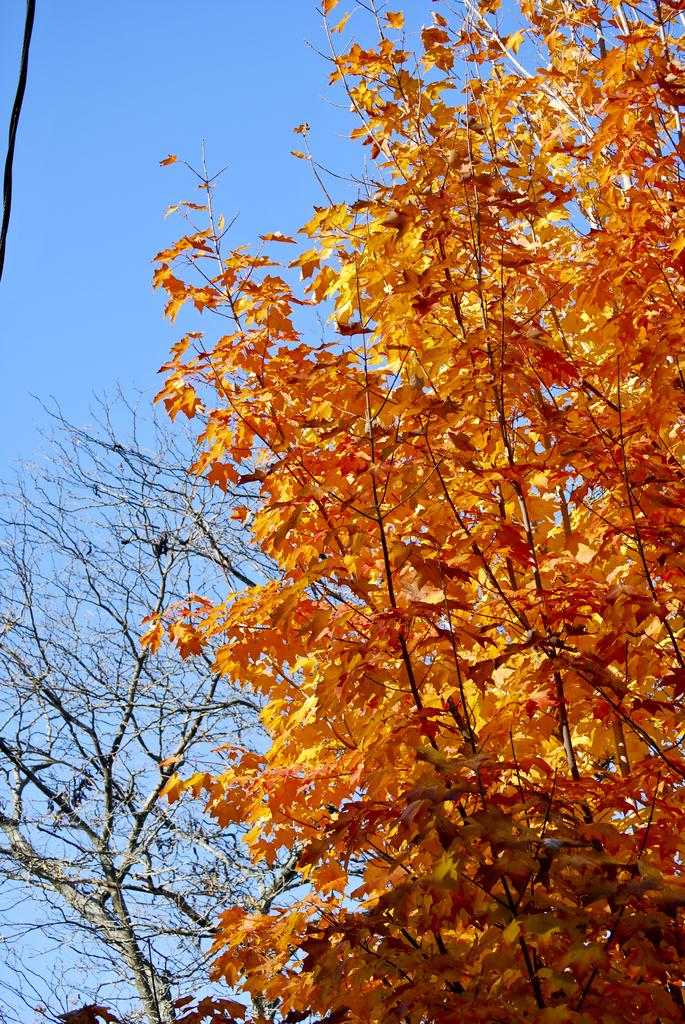What type of natural object can be seen in the image? There is a tree in the image. What is the color of the tree? The tree is brown in color. What can be seen in the background of the image? The sky is visible in the background of the image. What is the color of the sky? The sky is blue in color. What type of receipt can be seen falling from the tree in the image? There is no receipt present in the image, and the tree is not depicted as having any falling objects. 